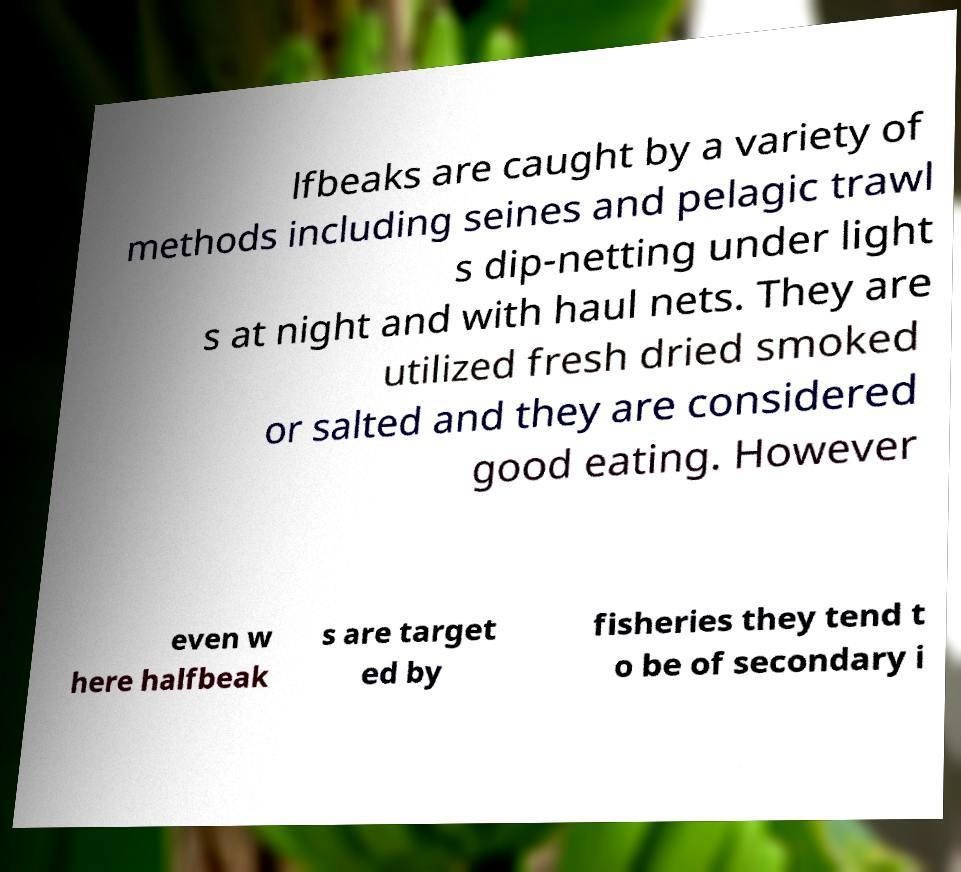For documentation purposes, I need the text within this image transcribed. Could you provide that? lfbeaks are caught by a variety of methods including seines and pelagic trawl s dip-netting under light s at night and with haul nets. They are utilized fresh dried smoked or salted and they are considered good eating. However even w here halfbeak s are target ed by fisheries they tend t o be of secondary i 